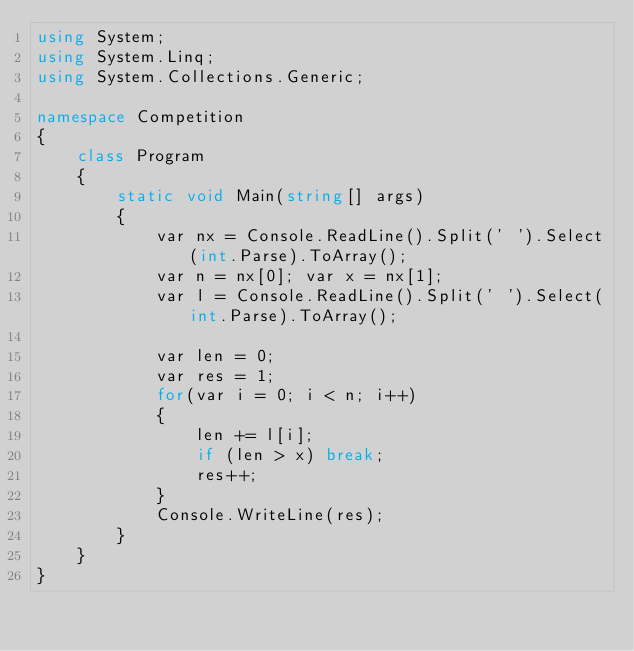<code> <loc_0><loc_0><loc_500><loc_500><_C#_>using System;
using System.Linq;
using System.Collections.Generic;

namespace Competition
{
    class Program
    {
        static void Main(string[] args)
        {
            var nx = Console.ReadLine().Split(' ').Select(int.Parse).ToArray();
            var n = nx[0]; var x = nx[1];
            var l = Console.ReadLine().Split(' ').Select(int.Parse).ToArray();

            var len = 0;
            var res = 1;
            for(var i = 0; i < n; i++)
            {
                len += l[i];
                if (len > x) break;
                res++;
            }
            Console.WriteLine(res);
        }
    }
}
</code> 